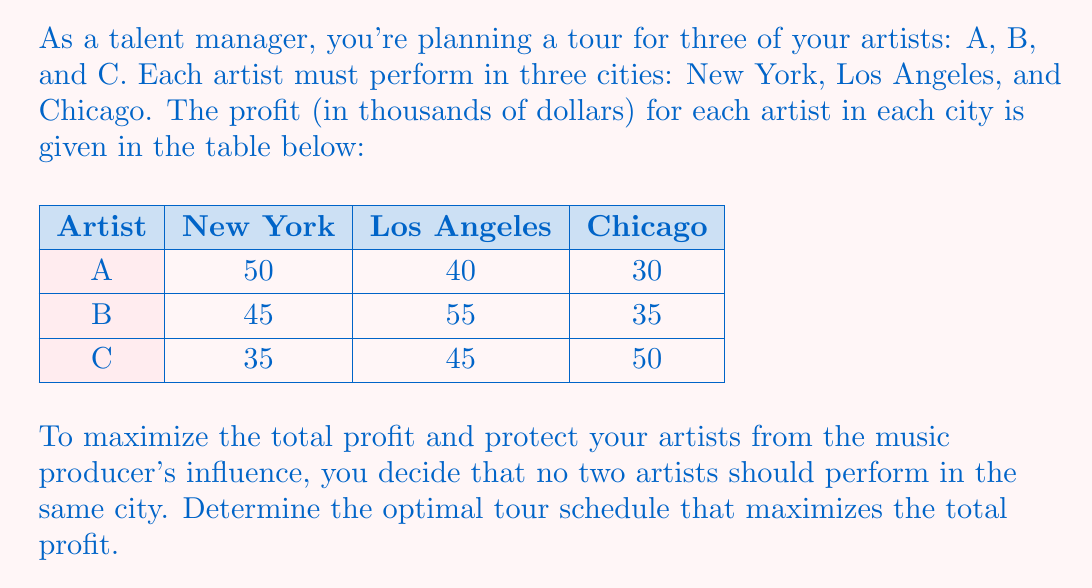Help me with this question. To solve this problem, we need to use a systematic approach to find the optimal combination. Here's how we can do it:

1) First, let's list all possible combinations where each artist performs in a different city:

   Combination 1: A in NY, B in LA, C in Chicago
   Combination 2: A in NY, B in Chicago, C in LA
   Combination 3: A in LA, B in NY, C in Chicago
   Combination 4: A in LA, B in Chicago, C in NY
   Combination 5: A in Chicago, B in NY, C in LA
   Combination 6: A in Chicago, B in LA, C in NY

2) Now, let's calculate the total profit for each combination:

   Combination 1: $50 + 55 + 50 = 155$
   Combination 2: $50 + 35 + 45 = 130$
   Combination 3: $40 + 45 + 50 = 135$
   Combination 4: $40 + 35 + 35 = 110$
   Combination 5: $30 + 45 + 45 = 120$
   Combination 6: $30 + 55 + 35 = 120$

3) The maximum profit is achieved with Combination 1, which gives a total profit of $155,000.

Therefore, the optimal tour schedule is:
- Artist A performs in New York
- Artist B performs in Los Angeles
- Artist C performs in Chicago
Answer: The optimal tour schedule is: Artist A in New York, Artist B in Los Angeles, and Artist C in Chicago, yielding a total profit of $155,000. 